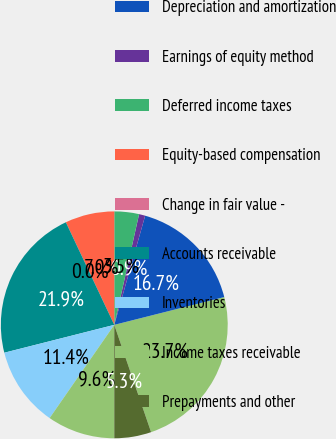<chart> <loc_0><loc_0><loc_500><loc_500><pie_chart><fcel>Net income<fcel>Depreciation and amortization<fcel>Earnings of equity method<fcel>Deferred income taxes<fcel>Equity-based compensation<fcel>Change in fair value -<fcel>Accounts receivable<fcel>Inventories<fcel>Income taxes receivable<fcel>Prepayments and other<nl><fcel>23.68%<fcel>16.67%<fcel>0.88%<fcel>3.51%<fcel>7.02%<fcel>0.0%<fcel>21.93%<fcel>11.4%<fcel>9.65%<fcel>5.26%<nl></chart> 